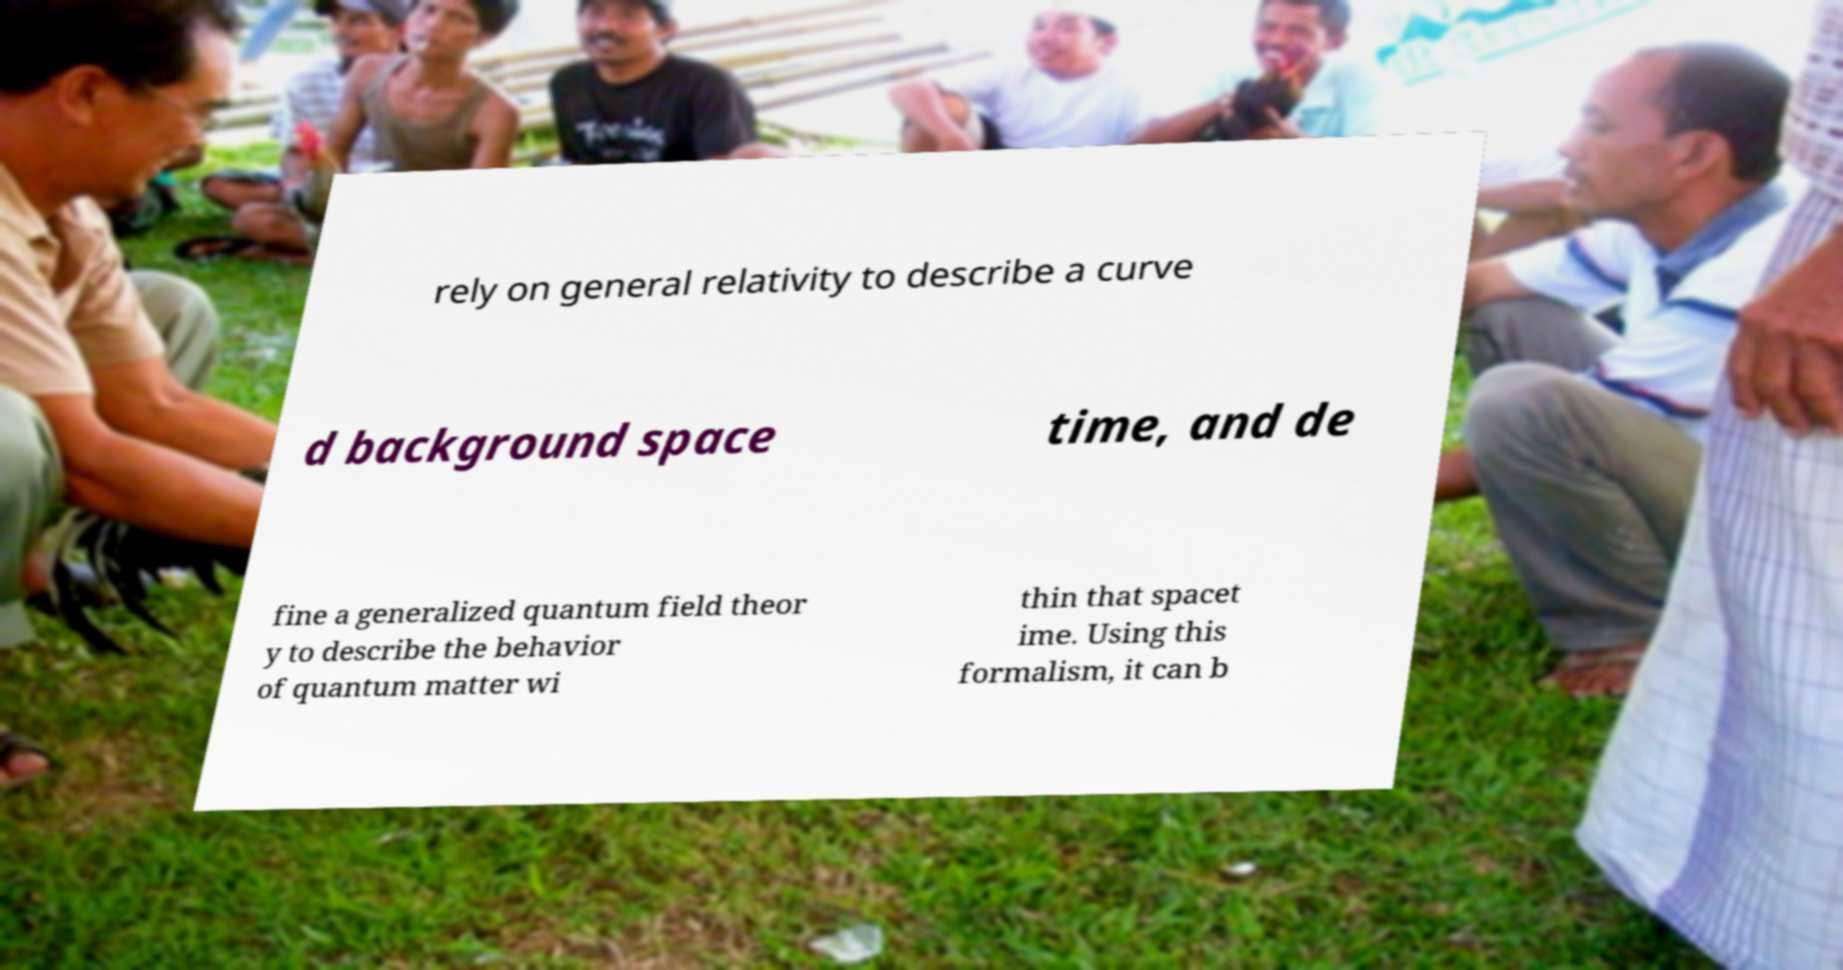Could you assist in decoding the text presented in this image and type it out clearly? rely on general relativity to describe a curve d background space time, and de fine a generalized quantum field theor y to describe the behavior of quantum matter wi thin that spacet ime. Using this formalism, it can b 